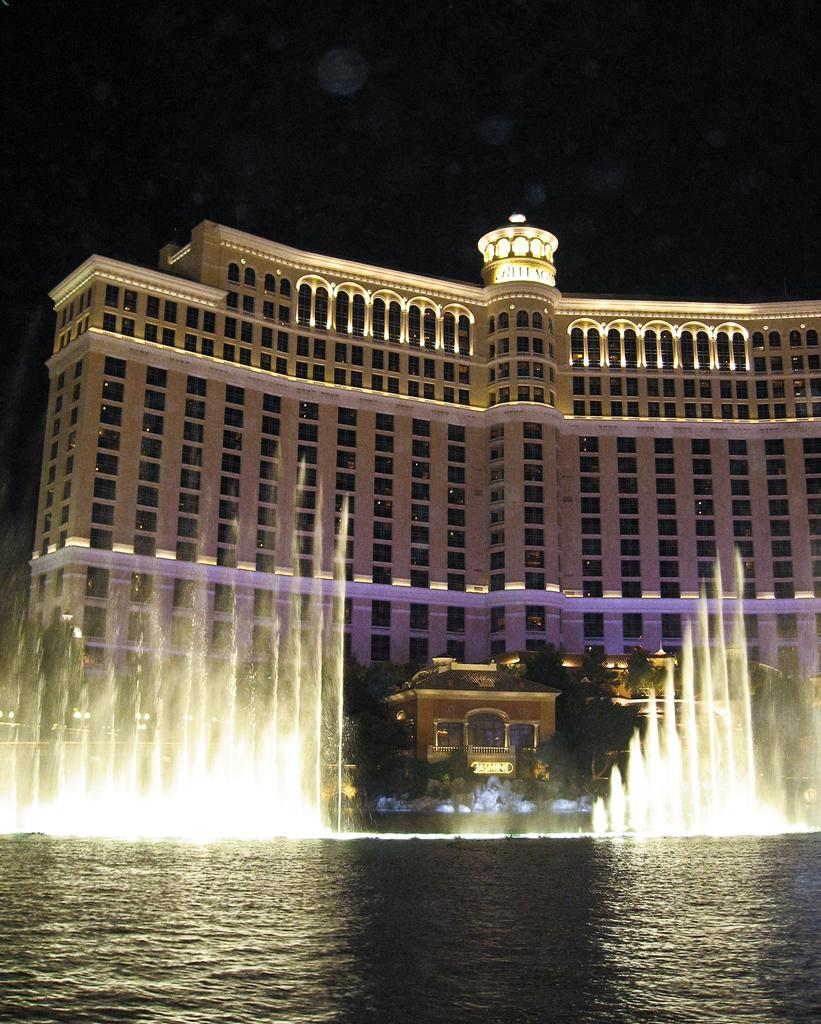What is at the bottom of the image? There is water at the bottom of the image, and trees are also visible there. What is located within the water? There is a fountain in the water. What can be observed about the water in the image? Waves are present in the water. What structures are visible in the middle of the image? There are buildings in the middle of the image, and one of them has a steeple. What features are present on the buildings? Windows are present on the buildings. What type of lighting is visible in the image? Lights and street lights are visible in the image. What is visible in the sky in the image? The sky is visible in the image. Where can the shop selling ice be found in the image? There is no shop selling ice present in the image. How many kittens are playing on the buildings in the image? There are no kittens present in the image. 